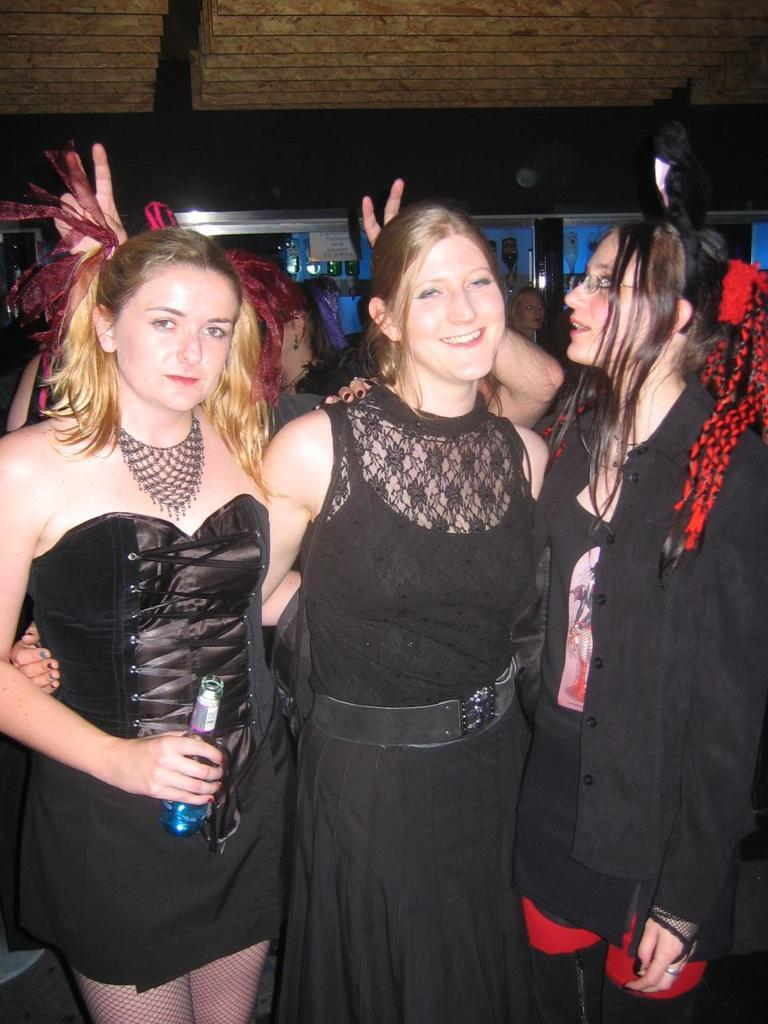What can be seen in the image involving multiple individuals? There is a group of people in the image. What is the woman in the image holding? The woman is holding a bottle. What can be seen behind the people in the image? There are objects visible behind the people. What part of the room can be seen at the top of the image? The ceiling is visible at the top of the image. What type of milk is being poured into the bottle by the woman in the image? There is no milk visible in the image, and the woman is not pouring anything into the bottle. 